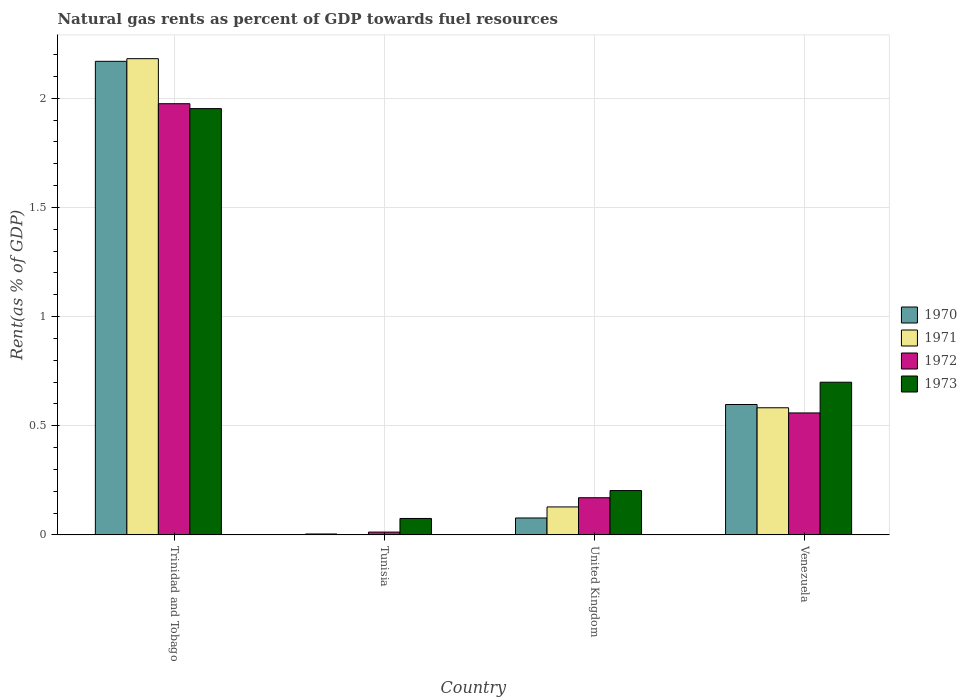How many groups of bars are there?
Provide a short and direct response. 4. Are the number of bars per tick equal to the number of legend labels?
Keep it short and to the point. Yes. How many bars are there on the 4th tick from the left?
Your answer should be very brief. 4. How many bars are there on the 4th tick from the right?
Make the answer very short. 4. In how many cases, is the number of bars for a given country not equal to the number of legend labels?
Give a very brief answer. 0. What is the matural gas rent in 1972 in United Kingdom?
Your response must be concise. 0.17. Across all countries, what is the maximum matural gas rent in 1970?
Make the answer very short. 2.17. Across all countries, what is the minimum matural gas rent in 1971?
Provide a short and direct response. 0. In which country was the matural gas rent in 1970 maximum?
Your answer should be compact. Trinidad and Tobago. In which country was the matural gas rent in 1970 minimum?
Your answer should be very brief. Tunisia. What is the total matural gas rent in 1973 in the graph?
Make the answer very short. 2.93. What is the difference between the matural gas rent in 1973 in Trinidad and Tobago and that in United Kingdom?
Make the answer very short. 1.75. What is the difference between the matural gas rent in 1972 in Venezuela and the matural gas rent in 1973 in Trinidad and Tobago?
Ensure brevity in your answer.  -1.39. What is the average matural gas rent in 1973 per country?
Offer a terse response. 0.73. What is the difference between the matural gas rent of/in 1972 and matural gas rent of/in 1971 in United Kingdom?
Ensure brevity in your answer.  0.04. In how many countries, is the matural gas rent in 1973 greater than 0.7 %?
Make the answer very short. 1. What is the ratio of the matural gas rent in 1973 in Tunisia to that in Venezuela?
Give a very brief answer. 0.11. What is the difference between the highest and the second highest matural gas rent in 1973?
Give a very brief answer. -1.25. What is the difference between the highest and the lowest matural gas rent in 1971?
Offer a terse response. 2.18. Is the sum of the matural gas rent in 1973 in Tunisia and Venezuela greater than the maximum matural gas rent in 1971 across all countries?
Offer a very short reply. No. Is it the case that in every country, the sum of the matural gas rent in 1971 and matural gas rent in 1970 is greater than the matural gas rent in 1973?
Your answer should be compact. No. How many bars are there?
Keep it short and to the point. 16. How many countries are there in the graph?
Offer a very short reply. 4. Where does the legend appear in the graph?
Give a very brief answer. Center right. What is the title of the graph?
Your answer should be very brief. Natural gas rents as percent of GDP towards fuel resources. What is the label or title of the Y-axis?
Give a very brief answer. Rent(as % of GDP). What is the Rent(as % of GDP) of 1970 in Trinidad and Tobago?
Offer a very short reply. 2.17. What is the Rent(as % of GDP) in 1971 in Trinidad and Tobago?
Provide a short and direct response. 2.18. What is the Rent(as % of GDP) of 1972 in Trinidad and Tobago?
Your response must be concise. 1.98. What is the Rent(as % of GDP) of 1973 in Trinidad and Tobago?
Your answer should be very brief. 1.95. What is the Rent(as % of GDP) in 1970 in Tunisia?
Provide a succinct answer. 0. What is the Rent(as % of GDP) in 1971 in Tunisia?
Make the answer very short. 0. What is the Rent(as % of GDP) of 1972 in Tunisia?
Make the answer very short. 0.01. What is the Rent(as % of GDP) in 1973 in Tunisia?
Give a very brief answer. 0.08. What is the Rent(as % of GDP) of 1970 in United Kingdom?
Your response must be concise. 0.08. What is the Rent(as % of GDP) in 1971 in United Kingdom?
Offer a terse response. 0.13. What is the Rent(as % of GDP) of 1972 in United Kingdom?
Provide a succinct answer. 0.17. What is the Rent(as % of GDP) of 1973 in United Kingdom?
Ensure brevity in your answer.  0.2. What is the Rent(as % of GDP) of 1970 in Venezuela?
Provide a short and direct response. 0.6. What is the Rent(as % of GDP) of 1971 in Venezuela?
Your answer should be compact. 0.58. What is the Rent(as % of GDP) in 1972 in Venezuela?
Make the answer very short. 0.56. What is the Rent(as % of GDP) of 1973 in Venezuela?
Your response must be concise. 0.7. Across all countries, what is the maximum Rent(as % of GDP) in 1970?
Provide a short and direct response. 2.17. Across all countries, what is the maximum Rent(as % of GDP) of 1971?
Your answer should be compact. 2.18. Across all countries, what is the maximum Rent(as % of GDP) in 1972?
Provide a succinct answer. 1.98. Across all countries, what is the maximum Rent(as % of GDP) of 1973?
Your answer should be very brief. 1.95. Across all countries, what is the minimum Rent(as % of GDP) of 1970?
Provide a short and direct response. 0. Across all countries, what is the minimum Rent(as % of GDP) of 1971?
Offer a terse response. 0. Across all countries, what is the minimum Rent(as % of GDP) of 1972?
Give a very brief answer. 0.01. Across all countries, what is the minimum Rent(as % of GDP) of 1973?
Provide a short and direct response. 0.08. What is the total Rent(as % of GDP) in 1970 in the graph?
Make the answer very short. 2.85. What is the total Rent(as % of GDP) of 1971 in the graph?
Offer a very short reply. 2.89. What is the total Rent(as % of GDP) of 1972 in the graph?
Provide a succinct answer. 2.72. What is the total Rent(as % of GDP) in 1973 in the graph?
Your response must be concise. 2.93. What is the difference between the Rent(as % of GDP) in 1970 in Trinidad and Tobago and that in Tunisia?
Your response must be concise. 2.17. What is the difference between the Rent(as % of GDP) in 1971 in Trinidad and Tobago and that in Tunisia?
Provide a succinct answer. 2.18. What is the difference between the Rent(as % of GDP) in 1972 in Trinidad and Tobago and that in Tunisia?
Your answer should be compact. 1.96. What is the difference between the Rent(as % of GDP) in 1973 in Trinidad and Tobago and that in Tunisia?
Your answer should be very brief. 1.88. What is the difference between the Rent(as % of GDP) of 1970 in Trinidad and Tobago and that in United Kingdom?
Give a very brief answer. 2.09. What is the difference between the Rent(as % of GDP) of 1971 in Trinidad and Tobago and that in United Kingdom?
Make the answer very short. 2.05. What is the difference between the Rent(as % of GDP) of 1972 in Trinidad and Tobago and that in United Kingdom?
Make the answer very short. 1.8. What is the difference between the Rent(as % of GDP) of 1973 in Trinidad and Tobago and that in United Kingdom?
Give a very brief answer. 1.75. What is the difference between the Rent(as % of GDP) in 1970 in Trinidad and Tobago and that in Venezuela?
Offer a very short reply. 1.57. What is the difference between the Rent(as % of GDP) in 1971 in Trinidad and Tobago and that in Venezuela?
Offer a terse response. 1.6. What is the difference between the Rent(as % of GDP) in 1972 in Trinidad and Tobago and that in Venezuela?
Offer a terse response. 1.42. What is the difference between the Rent(as % of GDP) in 1973 in Trinidad and Tobago and that in Venezuela?
Make the answer very short. 1.25. What is the difference between the Rent(as % of GDP) in 1970 in Tunisia and that in United Kingdom?
Give a very brief answer. -0.07. What is the difference between the Rent(as % of GDP) of 1971 in Tunisia and that in United Kingdom?
Give a very brief answer. -0.13. What is the difference between the Rent(as % of GDP) of 1972 in Tunisia and that in United Kingdom?
Keep it short and to the point. -0.16. What is the difference between the Rent(as % of GDP) of 1973 in Tunisia and that in United Kingdom?
Your response must be concise. -0.13. What is the difference between the Rent(as % of GDP) in 1970 in Tunisia and that in Venezuela?
Offer a terse response. -0.59. What is the difference between the Rent(as % of GDP) in 1971 in Tunisia and that in Venezuela?
Ensure brevity in your answer.  -0.58. What is the difference between the Rent(as % of GDP) of 1972 in Tunisia and that in Venezuela?
Your answer should be very brief. -0.55. What is the difference between the Rent(as % of GDP) in 1973 in Tunisia and that in Venezuela?
Your answer should be compact. -0.62. What is the difference between the Rent(as % of GDP) of 1970 in United Kingdom and that in Venezuela?
Your response must be concise. -0.52. What is the difference between the Rent(as % of GDP) in 1971 in United Kingdom and that in Venezuela?
Your response must be concise. -0.45. What is the difference between the Rent(as % of GDP) of 1972 in United Kingdom and that in Venezuela?
Make the answer very short. -0.39. What is the difference between the Rent(as % of GDP) in 1973 in United Kingdom and that in Venezuela?
Your response must be concise. -0.5. What is the difference between the Rent(as % of GDP) in 1970 in Trinidad and Tobago and the Rent(as % of GDP) in 1971 in Tunisia?
Offer a very short reply. 2.17. What is the difference between the Rent(as % of GDP) of 1970 in Trinidad and Tobago and the Rent(as % of GDP) of 1972 in Tunisia?
Offer a terse response. 2.16. What is the difference between the Rent(as % of GDP) in 1970 in Trinidad and Tobago and the Rent(as % of GDP) in 1973 in Tunisia?
Provide a short and direct response. 2.09. What is the difference between the Rent(as % of GDP) in 1971 in Trinidad and Tobago and the Rent(as % of GDP) in 1972 in Tunisia?
Your answer should be very brief. 2.17. What is the difference between the Rent(as % of GDP) of 1971 in Trinidad and Tobago and the Rent(as % of GDP) of 1973 in Tunisia?
Offer a terse response. 2.11. What is the difference between the Rent(as % of GDP) of 1972 in Trinidad and Tobago and the Rent(as % of GDP) of 1973 in Tunisia?
Provide a succinct answer. 1.9. What is the difference between the Rent(as % of GDP) of 1970 in Trinidad and Tobago and the Rent(as % of GDP) of 1971 in United Kingdom?
Your answer should be very brief. 2.04. What is the difference between the Rent(as % of GDP) in 1970 in Trinidad and Tobago and the Rent(as % of GDP) in 1972 in United Kingdom?
Offer a terse response. 2. What is the difference between the Rent(as % of GDP) of 1970 in Trinidad and Tobago and the Rent(as % of GDP) of 1973 in United Kingdom?
Offer a terse response. 1.97. What is the difference between the Rent(as % of GDP) in 1971 in Trinidad and Tobago and the Rent(as % of GDP) in 1972 in United Kingdom?
Your response must be concise. 2.01. What is the difference between the Rent(as % of GDP) of 1971 in Trinidad and Tobago and the Rent(as % of GDP) of 1973 in United Kingdom?
Give a very brief answer. 1.98. What is the difference between the Rent(as % of GDP) in 1972 in Trinidad and Tobago and the Rent(as % of GDP) in 1973 in United Kingdom?
Give a very brief answer. 1.77. What is the difference between the Rent(as % of GDP) of 1970 in Trinidad and Tobago and the Rent(as % of GDP) of 1971 in Venezuela?
Provide a succinct answer. 1.59. What is the difference between the Rent(as % of GDP) in 1970 in Trinidad and Tobago and the Rent(as % of GDP) in 1972 in Venezuela?
Your answer should be compact. 1.61. What is the difference between the Rent(as % of GDP) of 1970 in Trinidad and Tobago and the Rent(as % of GDP) of 1973 in Venezuela?
Provide a succinct answer. 1.47. What is the difference between the Rent(as % of GDP) in 1971 in Trinidad and Tobago and the Rent(as % of GDP) in 1972 in Venezuela?
Your answer should be compact. 1.62. What is the difference between the Rent(as % of GDP) of 1971 in Trinidad and Tobago and the Rent(as % of GDP) of 1973 in Venezuela?
Your answer should be very brief. 1.48. What is the difference between the Rent(as % of GDP) of 1972 in Trinidad and Tobago and the Rent(as % of GDP) of 1973 in Venezuela?
Ensure brevity in your answer.  1.28. What is the difference between the Rent(as % of GDP) in 1970 in Tunisia and the Rent(as % of GDP) in 1971 in United Kingdom?
Make the answer very short. -0.12. What is the difference between the Rent(as % of GDP) in 1970 in Tunisia and the Rent(as % of GDP) in 1972 in United Kingdom?
Give a very brief answer. -0.17. What is the difference between the Rent(as % of GDP) in 1970 in Tunisia and the Rent(as % of GDP) in 1973 in United Kingdom?
Give a very brief answer. -0.2. What is the difference between the Rent(as % of GDP) of 1971 in Tunisia and the Rent(as % of GDP) of 1972 in United Kingdom?
Your response must be concise. -0.17. What is the difference between the Rent(as % of GDP) of 1971 in Tunisia and the Rent(as % of GDP) of 1973 in United Kingdom?
Your answer should be compact. -0.2. What is the difference between the Rent(as % of GDP) in 1972 in Tunisia and the Rent(as % of GDP) in 1973 in United Kingdom?
Provide a short and direct response. -0.19. What is the difference between the Rent(as % of GDP) in 1970 in Tunisia and the Rent(as % of GDP) in 1971 in Venezuela?
Your answer should be very brief. -0.58. What is the difference between the Rent(as % of GDP) in 1970 in Tunisia and the Rent(as % of GDP) in 1972 in Venezuela?
Ensure brevity in your answer.  -0.55. What is the difference between the Rent(as % of GDP) in 1970 in Tunisia and the Rent(as % of GDP) in 1973 in Venezuela?
Your answer should be very brief. -0.7. What is the difference between the Rent(as % of GDP) in 1971 in Tunisia and the Rent(as % of GDP) in 1972 in Venezuela?
Ensure brevity in your answer.  -0.56. What is the difference between the Rent(as % of GDP) in 1971 in Tunisia and the Rent(as % of GDP) in 1973 in Venezuela?
Make the answer very short. -0.7. What is the difference between the Rent(as % of GDP) in 1972 in Tunisia and the Rent(as % of GDP) in 1973 in Venezuela?
Your answer should be very brief. -0.69. What is the difference between the Rent(as % of GDP) in 1970 in United Kingdom and the Rent(as % of GDP) in 1971 in Venezuela?
Offer a very short reply. -0.5. What is the difference between the Rent(as % of GDP) in 1970 in United Kingdom and the Rent(as % of GDP) in 1972 in Venezuela?
Give a very brief answer. -0.48. What is the difference between the Rent(as % of GDP) of 1970 in United Kingdom and the Rent(as % of GDP) of 1973 in Venezuela?
Offer a terse response. -0.62. What is the difference between the Rent(as % of GDP) of 1971 in United Kingdom and the Rent(as % of GDP) of 1972 in Venezuela?
Provide a short and direct response. -0.43. What is the difference between the Rent(as % of GDP) in 1971 in United Kingdom and the Rent(as % of GDP) in 1973 in Venezuela?
Your response must be concise. -0.57. What is the difference between the Rent(as % of GDP) of 1972 in United Kingdom and the Rent(as % of GDP) of 1973 in Venezuela?
Offer a very short reply. -0.53. What is the average Rent(as % of GDP) of 1970 per country?
Offer a terse response. 0.71. What is the average Rent(as % of GDP) of 1971 per country?
Offer a very short reply. 0.72. What is the average Rent(as % of GDP) in 1972 per country?
Your answer should be compact. 0.68. What is the average Rent(as % of GDP) of 1973 per country?
Your answer should be compact. 0.73. What is the difference between the Rent(as % of GDP) in 1970 and Rent(as % of GDP) in 1971 in Trinidad and Tobago?
Your answer should be very brief. -0.01. What is the difference between the Rent(as % of GDP) in 1970 and Rent(as % of GDP) in 1972 in Trinidad and Tobago?
Make the answer very short. 0.19. What is the difference between the Rent(as % of GDP) in 1970 and Rent(as % of GDP) in 1973 in Trinidad and Tobago?
Your answer should be compact. 0.22. What is the difference between the Rent(as % of GDP) in 1971 and Rent(as % of GDP) in 1972 in Trinidad and Tobago?
Keep it short and to the point. 0.21. What is the difference between the Rent(as % of GDP) of 1971 and Rent(as % of GDP) of 1973 in Trinidad and Tobago?
Your answer should be very brief. 0.23. What is the difference between the Rent(as % of GDP) of 1972 and Rent(as % of GDP) of 1973 in Trinidad and Tobago?
Make the answer very short. 0.02. What is the difference between the Rent(as % of GDP) in 1970 and Rent(as % of GDP) in 1971 in Tunisia?
Provide a succinct answer. 0. What is the difference between the Rent(as % of GDP) in 1970 and Rent(as % of GDP) in 1972 in Tunisia?
Ensure brevity in your answer.  -0.01. What is the difference between the Rent(as % of GDP) in 1970 and Rent(as % of GDP) in 1973 in Tunisia?
Ensure brevity in your answer.  -0.07. What is the difference between the Rent(as % of GDP) in 1971 and Rent(as % of GDP) in 1972 in Tunisia?
Keep it short and to the point. -0.01. What is the difference between the Rent(as % of GDP) in 1971 and Rent(as % of GDP) in 1973 in Tunisia?
Make the answer very short. -0.07. What is the difference between the Rent(as % of GDP) of 1972 and Rent(as % of GDP) of 1973 in Tunisia?
Offer a terse response. -0.06. What is the difference between the Rent(as % of GDP) of 1970 and Rent(as % of GDP) of 1971 in United Kingdom?
Offer a very short reply. -0.05. What is the difference between the Rent(as % of GDP) of 1970 and Rent(as % of GDP) of 1972 in United Kingdom?
Provide a succinct answer. -0.09. What is the difference between the Rent(as % of GDP) in 1970 and Rent(as % of GDP) in 1973 in United Kingdom?
Keep it short and to the point. -0.13. What is the difference between the Rent(as % of GDP) of 1971 and Rent(as % of GDP) of 1972 in United Kingdom?
Offer a very short reply. -0.04. What is the difference between the Rent(as % of GDP) of 1971 and Rent(as % of GDP) of 1973 in United Kingdom?
Offer a very short reply. -0.07. What is the difference between the Rent(as % of GDP) in 1972 and Rent(as % of GDP) in 1973 in United Kingdom?
Ensure brevity in your answer.  -0.03. What is the difference between the Rent(as % of GDP) of 1970 and Rent(as % of GDP) of 1971 in Venezuela?
Make the answer very short. 0.01. What is the difference between the Rent(as % of GDP) in 1970 and Rent(as % of GDP) in 1972 in Venezuela?
Your response must be concise. 0.04. What is the difference between the Rent(as % of GDP) in 1970 and Rent(as % of GDP) in 1973 in Venezuela?
Keep it short and to the point. -0.1. What is the difference between the Rent(as % of GDP) of 1971 and Rent(as % of GDP) of 1972 in Venezuela?
Give a very brief answer. 0.02. What is the difference between the Rent(as % of GDP) in 1971 and Rent(as % of GDP) in 1973 in Venezuela?
Offer a very short reply. -0.12. What is the difference between the Rent(as % of GDP) in 1972 and Rent(as % of GDP) in 1973 in Venezuela?
Provide a short and direct response. -0.14. What is the ratio of the Rent(as % of GDP) of 1970 in Trinidad and Tobago to that in Tunisia?
Your response must be concise. 511.49. What is the ratio of the Rent(as % of GDP) in 1971 in Trinidad and Tobago to that in Tunisia?
Ensure brevity in your answer.  2940.6. What is the ratio of the Rent(as % of GDP) of 1972 in Trinidad and Tobago to that in Tunisia?
Your answer should be compact. 153.39. What is the ratio of the Rent(as % of GDP) in 1973 in Trinidad and Tobago to that in Tunisia?
Offer a very short reply. 25.94. What is the ratio of the Rent(as % of GDP) of 1970 in Trinidad and Tobago to that in United Kingdom?
Provide a succinct answer. 27.99. What is the ratio of the Rent(as % of GDP) of 1971 in Trinidad and Tobago to that in United Kingdom?
Ensure brevity in your answer.  17.03. What is the ratio of the Rent(as % of GDP) of 1972 in Trinidad and Tobago to that in United Kingdom?
Your response must be concise. 11.6. What is the ratio of the Rent(as % of GDP) of 1973 in Trinidad and Tobago to that in United Kingdom?
Offer a terse response. 9.62. What is the ratio of the Rent(as % of GDP) in 1970 in Trinidad and Tobago to that in Venezuela?
Your answer should be compact. 3.63. What is the ratio of the Rent(as % of GDP) in 1971 in Trinidad and Tobago to that in Venezuela?
Make the answer very short. 3.75. What is the ratio of the Rent(as % of GDP) of 1972 in Trinidad and Tobago to that in Venezuela?
Keep it short and to the point. 3.54. What is the ratio of the Rent(as % of GDP) in 1973 in Trinidad and Tobago to that in Venezuela?
Make the answer very short. 2.79. What is the ratio of the Rent(as % of GDP) of 1970 in Tunisia to that in United Kingdom?
Keep it short and to the point. 0.05. What is the ratio of the Rent(as % of GDP) in 1971 in Tunisia to that in United Kingdom?
Provide a succinct answer. 0.01. What is the ratio of the Rent(as % of GDP) of 1972 in Tunisia to that in United Kingdom?
Your answer should be very brief. 0.08. What is the ratio of the Rent(as % of GDP) in 1973 in Tunisia to that in United Kingdom?
Make the answer very short. 0.37. What is the ratio of the Rent(as % of GDP) in 1970 in Tunisia to that in Venezuela?
Ensure brevity in your answer.  0.01. What is the ratio of the Rent(as % of GDP) of 1971 in Tunisia to that in Venezuela?
Your answer should be very brief. 0. What is the ratio of the Rent(as % of GDP) of 1972 in Tunisia to that in Venezuela?
Your answer should be very brief. 0.02. What is the ratio of the Rent(as % of GDP) in 1973 in Tunisia to that in Venezuela?
Offer a terse response. 0.11. What is the ratio of the Rent(as % of GDP) of 1970 in United Kingdom to that in Venezuela?
Give a very brief answer. 0.13. What is the ratio of the Rent(as % of GDP) in 1971 in United Kingdom to that in Venezuela?
Make the answer very short. 0.22. What is the ratio of the Rent(as % of GDP) in 1972 in United Kingdom to that in Venezuela?
Your answer should be very brief. 0.3. What is the ratio of the Rent(as % of GDP) of 1973 in United Kingdom to that in Venezuela?
Provide a succinct answer. 0.29. What is the difference between the highest and the second highest Rent(as % of GDP) of 1970?
Keep it short and to the point. 1.57. What is the difference between the highest and the second highest Rent(as % of GDP) in 1971?
Give a very brief answer. 1.6. What is the difference between the highest and the second highest Rent(as % of GDP) of 1972?
Offer a very short reply. 1.42. What is the difference between the highest and the second highest Rent(as % of GDP) in 1973?
Provide a succinct answer. 1.25. What is the difference between the highest and the lowest Rent(as % of GDP) of 1970?
Your answer should be compact. 2.17. What is the difference between the highest and the lowest Rent(as % of GDP) in 1971?
Give a very brief answer. 2.18. What is the difference between the highest and the lowest Rent(as % of GDP) in 1972?
Ensure brevity in your answer.  1.96. What is the difference between the highest and the lowest Rent(as % of GDP) in 1973?
Ensure brevity in your answer.  1.88. 